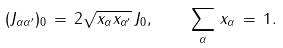Convert formula to latex. <formula><loc_0><loc_0><loc_500><loc_500>( J _ { \alpha \alpha ^ { \prime } } ) _ { 0 } \, = \, 2 \sqrt { x _ { \alpha } x _ { \alpha ^ { \prime } } } \, J _ { 0 } , \quad \sum _ { \alpha } \, x _ { \alpha } \, = \, 1 .</formula> 